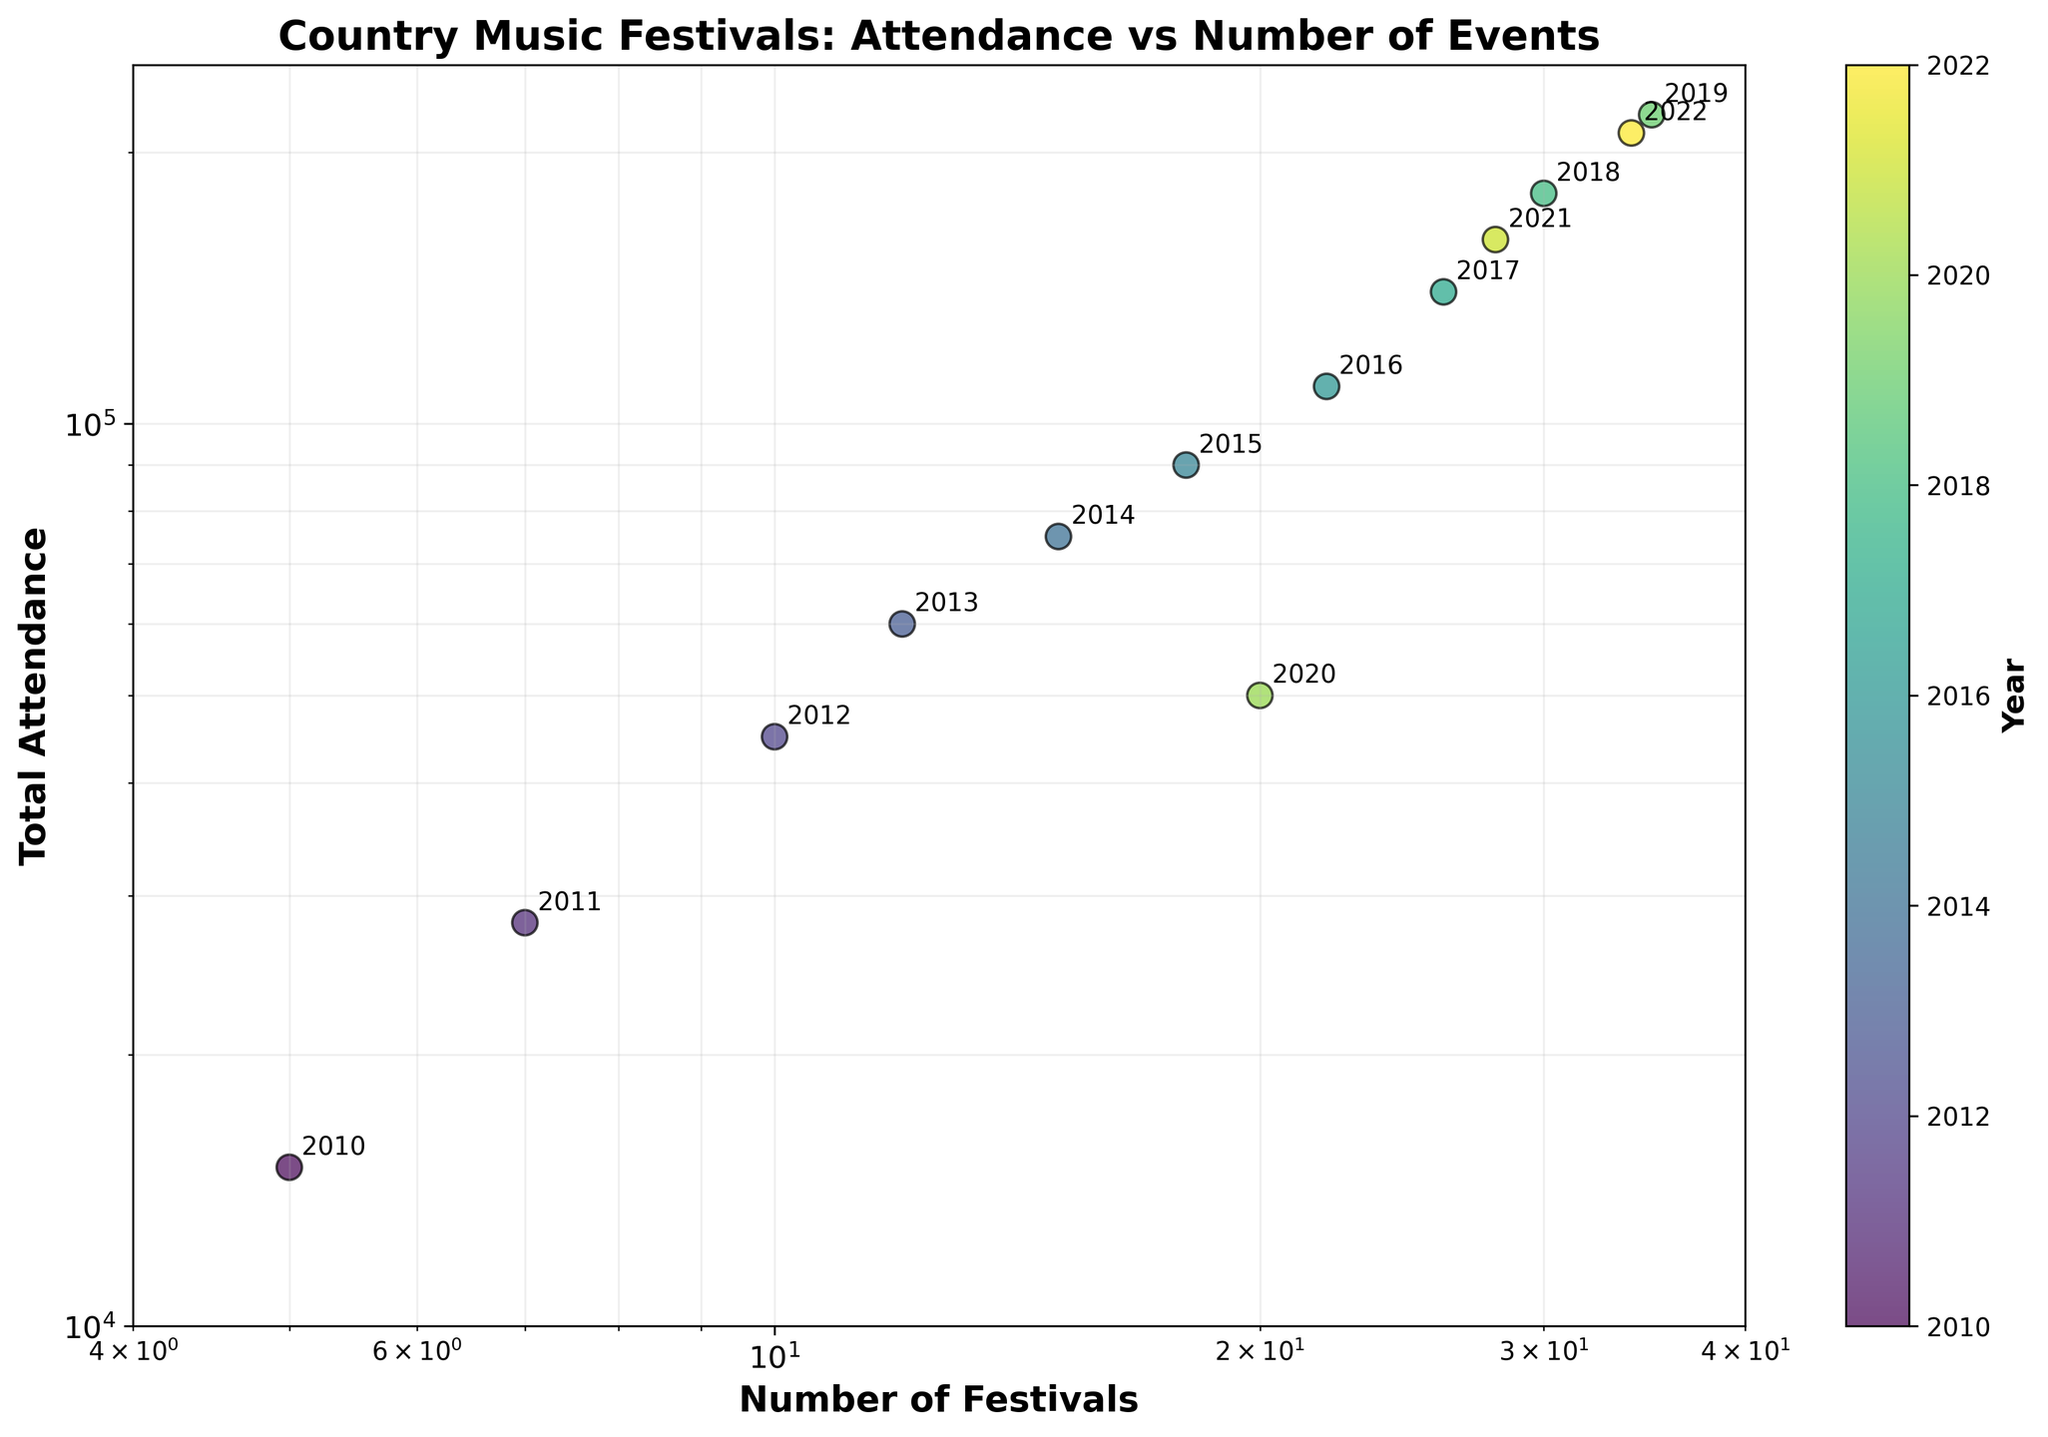What is the title of the scatter plot? The title is located at the top of the plot and is "Country Music Festivals: Attendance vs Number of Events".
Answer: Country Music Festivals: Attendance vs Number of Events Which year had the highest total attendance? To determine the year with the highest total attendance, look at the color bar to identify the year corresponding to the highest y-axis value on the plot. The maximum y-value is 220000, which corresponds to 2019.
Answer: 2019 How many data points are plotted for Number of Festivals? Count the number of points shown on the x-axis that represent different numbers of festivals. Each year from 2010 to 2022 corresponds to a data point. Since 13 years are represented, there are 13 data points.
Answer: 13 What can be said about the trend between Number of Festivals and Total Attendance over time? Observe the scatter plot. As the number of festivals increases, the total attendance also generally increases, except for the years 2020 and 2021 where there is a noticeable drop and recovery. This suggests a positive correlation between the number of festivals and total attendance with an anomaly around 2020.
Answer: Positive correlation with an anomaly in 2020 Which two years have the closest number of festivals with a significant difference in total attendance? Find the years with similar x-axis values but significantly different y-axis values. 2020 and 2021 both have 20 and 28 festivals respectively, but their total attendances are 50000 and 160000, showing a significant difference.
Answer: 2020 and 2021 What was the total attendance in 2020, and how did it compare to 2019? Check the scatter plot points labeled 2020 and 2019. The total attendance in 2020 was 50000 and in 2019 it was 220000. The attendance in 2020 was significantly lower compared to 2019.
Answer: 2020: 50000, 2019: 220000 What is the range of total attendance shown in the plot? Identify the minimum and maximum y-values on the log scale of the y-axis. The minimum is 10000, and the maximum is 250000.
Answer: 10000 to 250000 In which year did the number of festivals surpass 25, and what was the total attendance that year? Locate years with an x-axis value above 25. The point for 2017 corresponds to an x-axis value of 26 festivals and a total attendance of 140000.
Answer: 2017, 140000 During which year is there the largest difference in total attendance compared to its previous year? Calculate the year-to-year differences in the total attendance values shown in the scatter plot. The largest difference occurs between 2019 (220000) and 2020 (50000), which is a drop of 170000.
Answer: 2020 Which year had a similar number of festivals to 2012 but a higher total attendance? Compare the data points for each year. The point in 2018 has a comparable number of festivals (30) to 2012 (10), but with a higher total attendance (180000 vs 45000).
Answer: 2018 